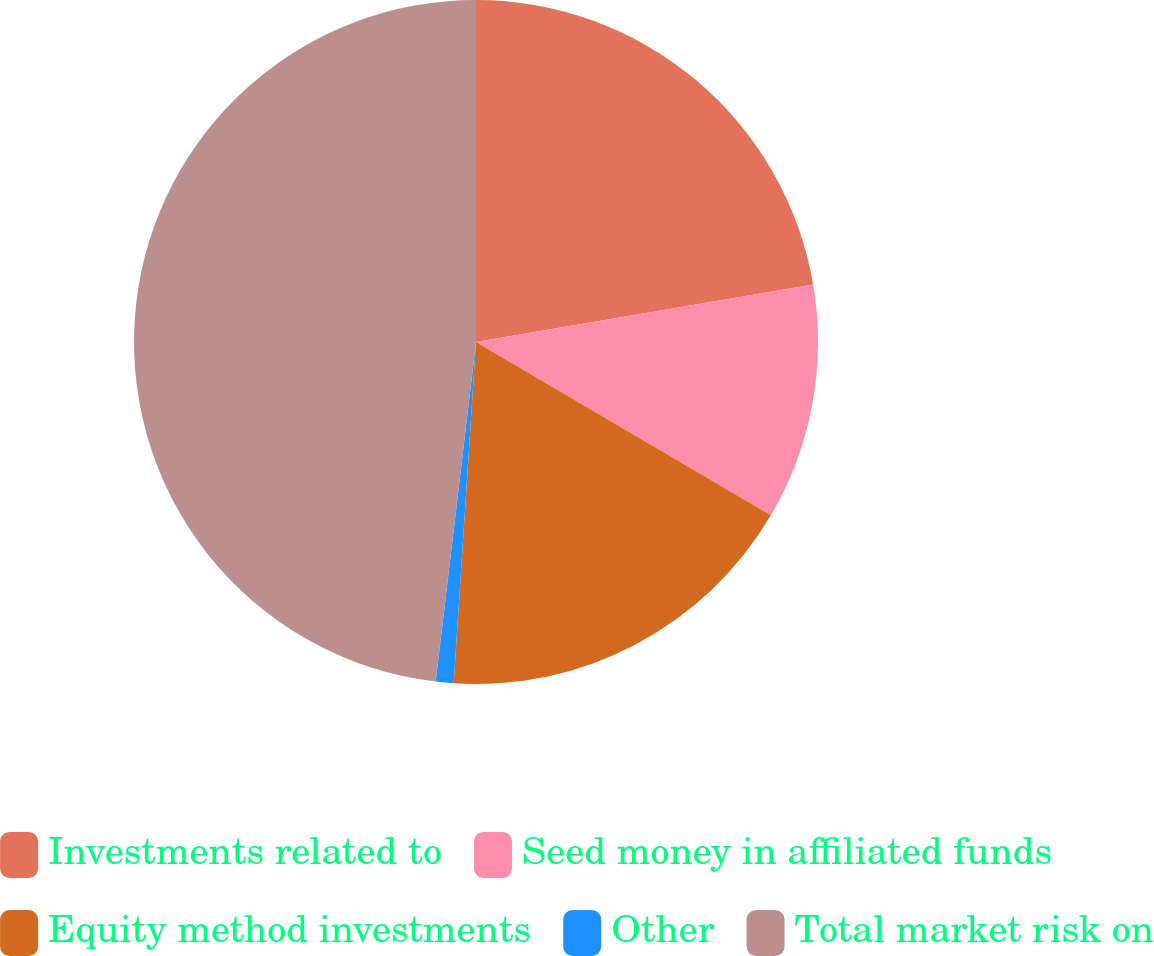<chart> <loc_0><loc_0><loc_500><loc_500><pie_chart><fcel>Investments related to<fcel>Seed money in affiliated funds<fcel>Equity method investments<fcel>Other<fcel>Total market risk on<nl><fcel>22.31%<fcel>11.15%<fcel>17.58%<fcel>0.84%<fcel>48.12%<nl></chart> 